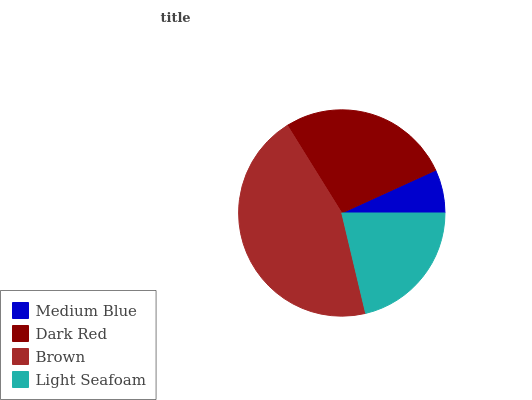Is Medium Blue the minimum?
Answer yes or no. Yes. Is Brown the maximum?
Answer yes or no. Yes. Is Dark Red the minimum?
Answer yes or no. No. Is Dark Red the maximum?
Answer yes or no. No. Is Dark Red greater than Medium Blue?
Answer yes or no. Yes. Is Medium Blue less than Dark Red?
Answer yes or no. Yes. Is Medium Blue greater than Dark Red?
Answer yes or no. No. Is Dark Red less than Medium Blue?
Answer yes or no. No. Is Dark Red the high median?
Answer yes or no. Yes. Is Light Seafoam the low median?
Answer yes or no. Yes. Is Light Seafoam the high median?
Answer yes or no. No. Is Dark Red the low median?
Answer yes or no. No. 